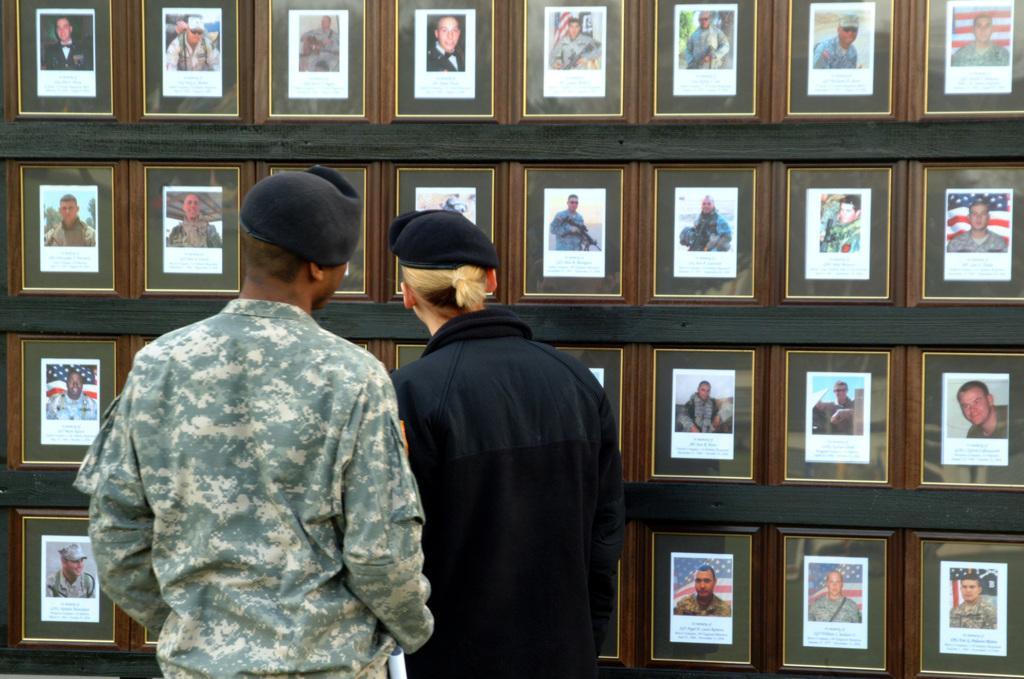Please provide a concise description of this image. In this image I see many photo frames on the wall and I see 2 persons over here in which one of them is wearing uniform and another person is wearing black dress and I see that both of them are wearing caps. 